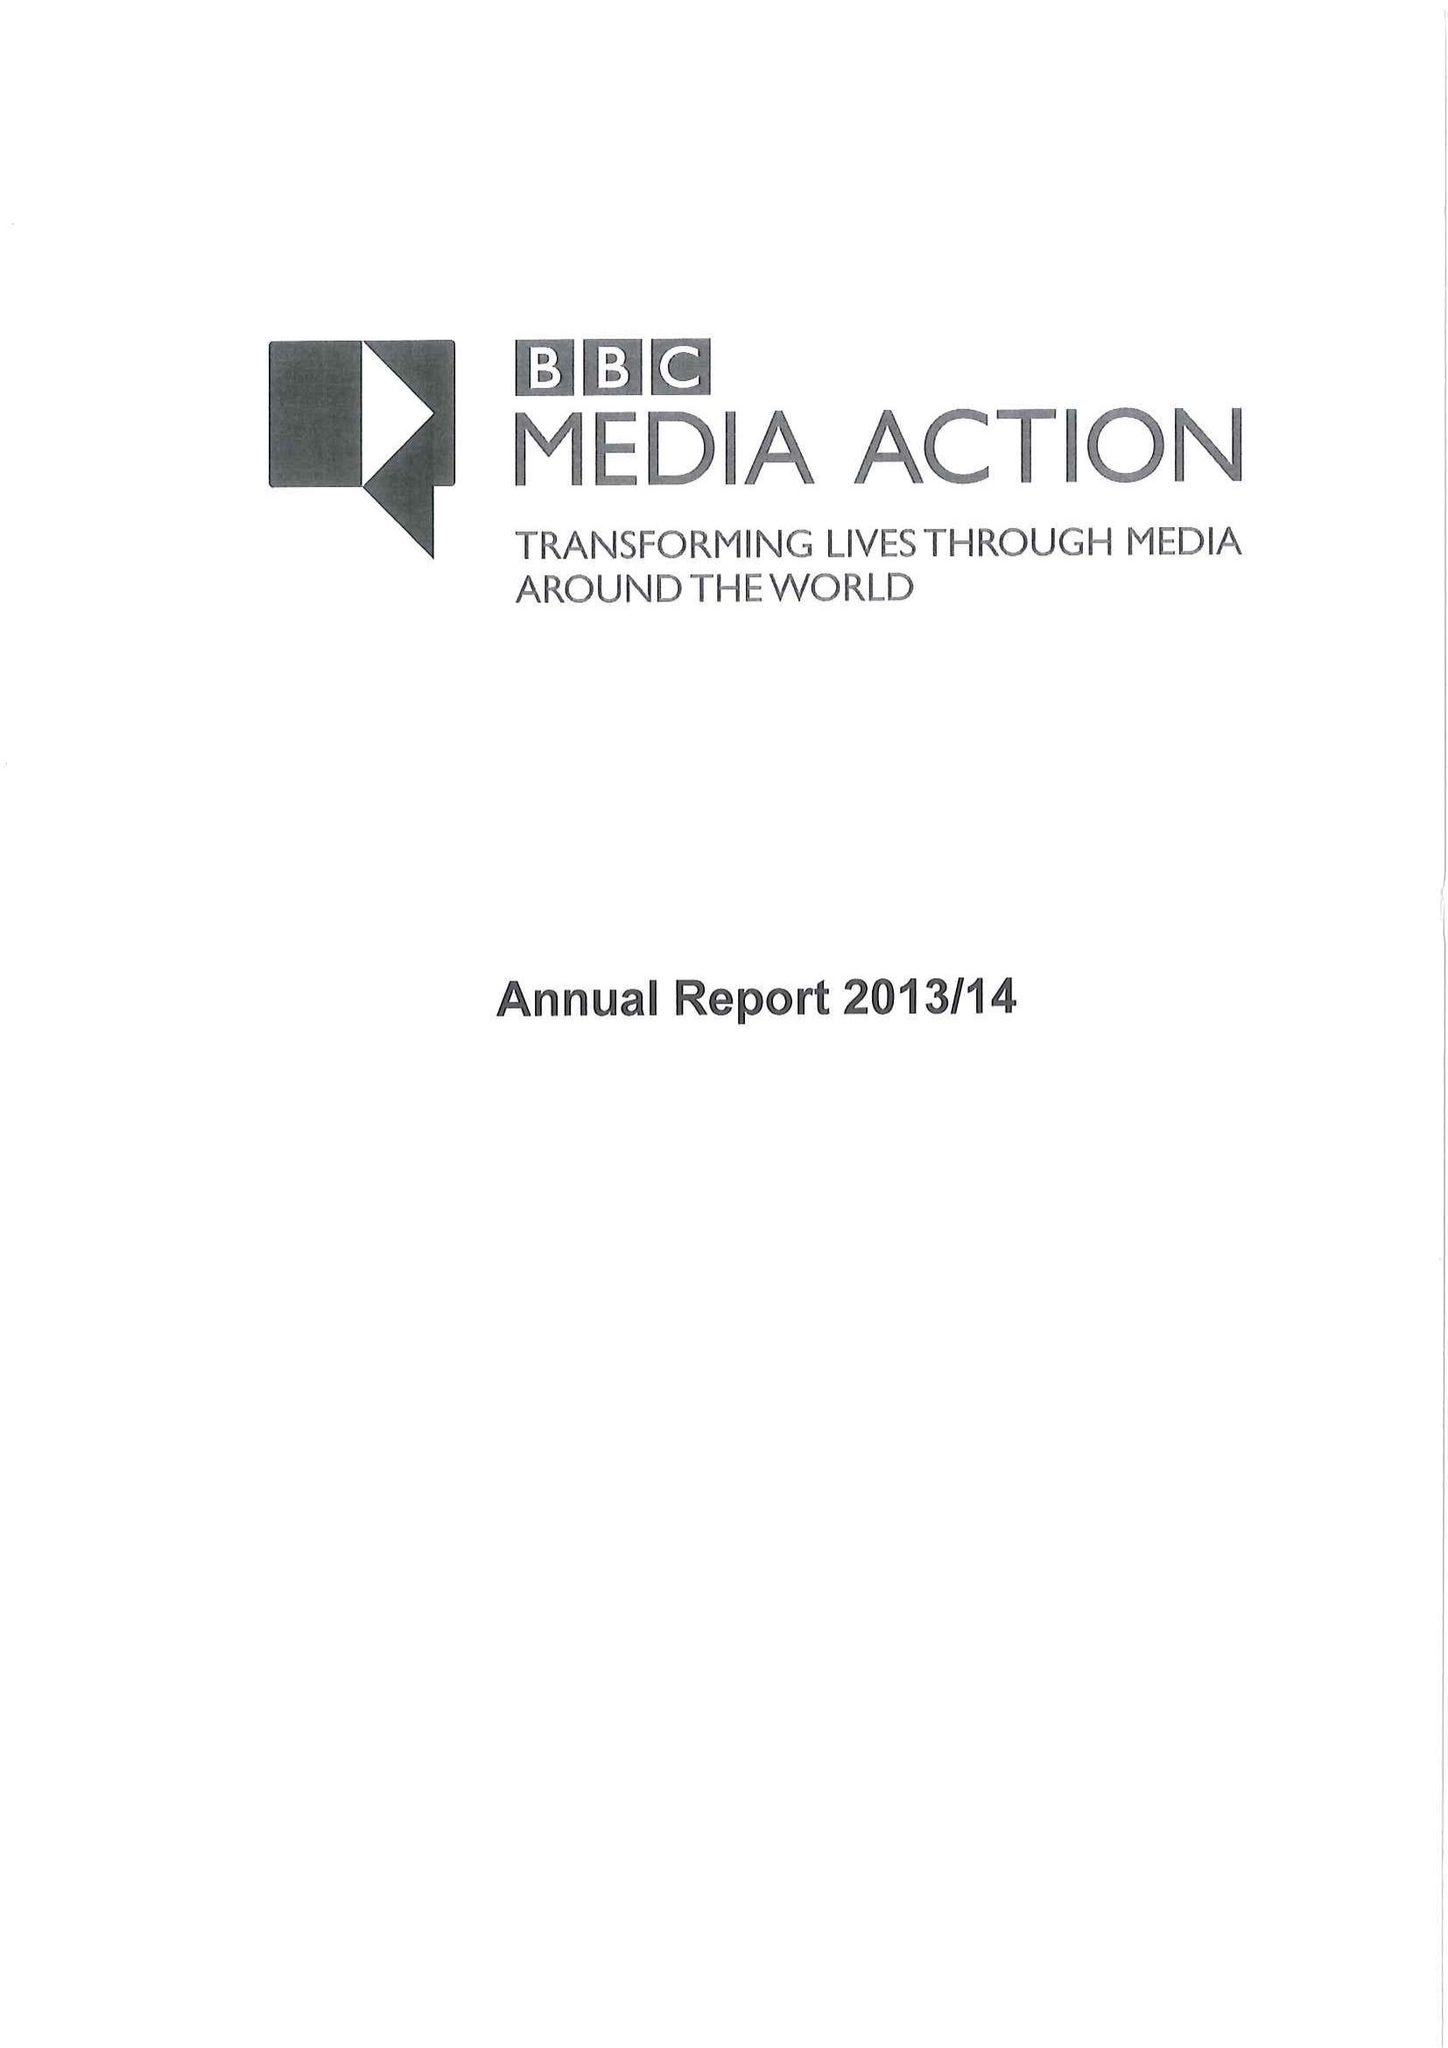What is the value for the address__postcode?
Answer the question using a single word or phrase. W1A 1AA 